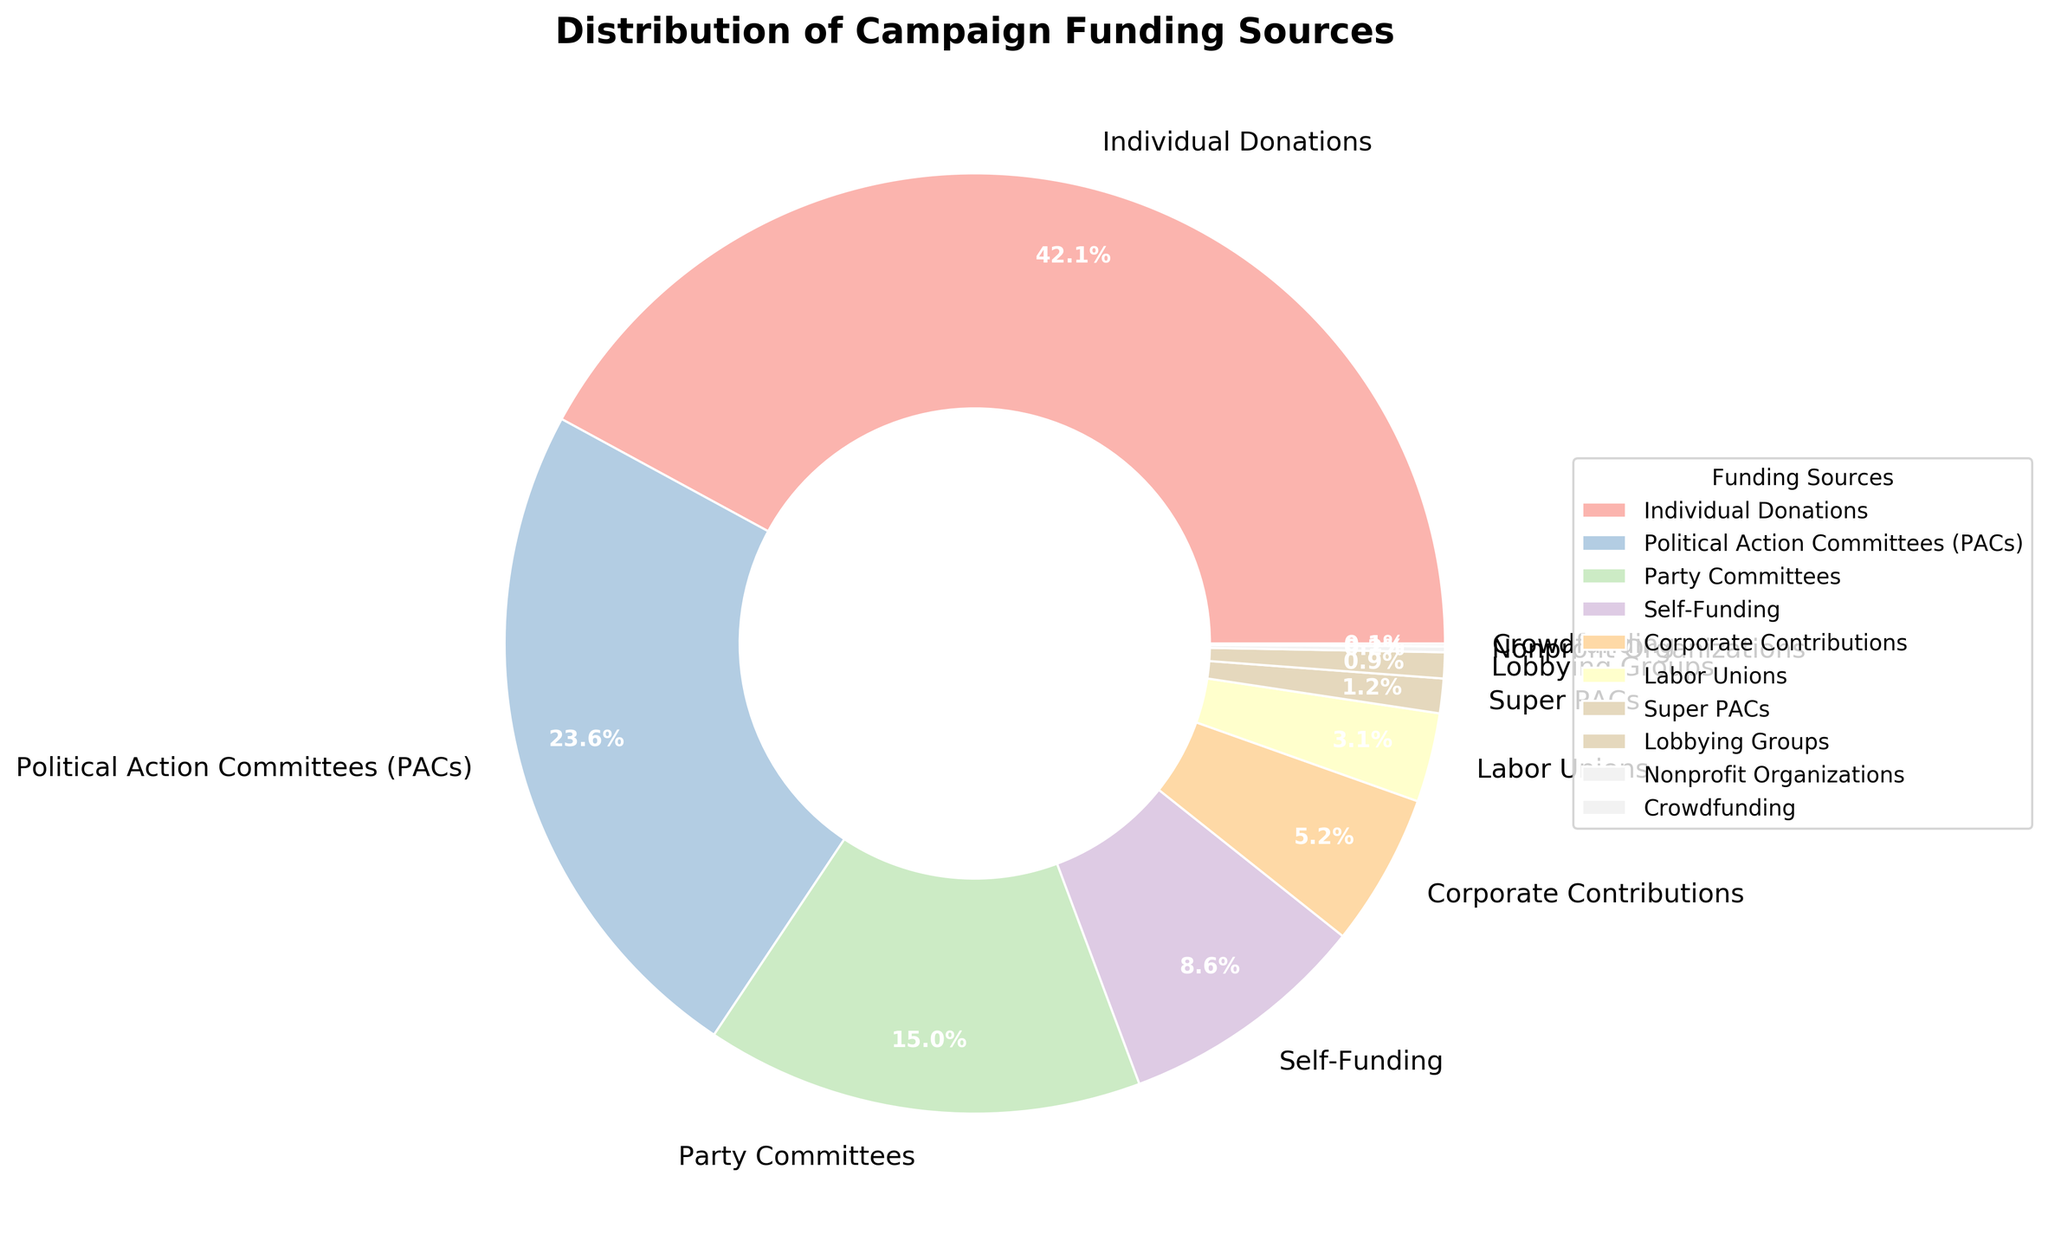Which funding source has the largest percentage? The pie chart shows that "Individual Donations" has the largest slice, representing 42.5% of the total campaign funding sources.
Answer: Individual Donations What is the combined percentage of "Individual Donations" and "Political Action Committees (PACs)"? According to the pie chart, "Individual Donations" account for 42.5% and "Political Action Committees (PACs)" account for 23.8%. Adding these together, 42.5 + 23.8 = 66.3%.
Answer: 66.3% Which two funding sources together account for the smallest percentage? The chart shows that "Crowdfunding" and "Nonprofit Organizations" have the smallest individual percentages at 0.1% and 0.2%, respectively. Together, they sum up to 0.1 + 0.2 = 0.3%.
Answer: Crowdfunding and Nonprofit Organizations By how much does the percentage of "Corporate Contributions" exceed that of "Labor Unions"? From the pie chart, "Corporate Contributions" have a percentage of 5.3%, and "Labor Unions" have 3.1%. The difference is 5.3 - 3.1 = 2.2%.
Answer: 2.2% What is the percentage difference between the largest and the smallest funding sources? The largest funding source is "Individual Donations" at 42.5%, and the smallest is "Crowdfunding" at 0.1%. The difference is 42.5 - 0.1 = 42.4%.
Answer: 42.4% What percentage of the campaign funding comes from "Self-Funding" and "Party Committees" combined? According to the chart, "Self-Funding" has a percentage of 8.7% and "Party Committees" has 15.2%. Adding these together, 8.7 + 15.2 = 23.9%.
Answer: 23.9% How many funding sources have a percentage greater than or equal to 5%? From the pie chart, the funding sources that meet this criterion are "Individual Donations" (42.5%), "Political Action Committees (PACs)" (23.8%), "Party Committees" (15.2%), and "Self-Funding" (8.7%). There are 4 such funding sources.
Answer: 4 What is the total percentage of all sources other than "Individual Donations"? The percentage for "Individual Donations" is 42.5%. The total percentage for all sources is 100%. Therefore, the total for all other sources is 100 - 42.5 = 57.5%.
Answer: 57.5% How does the size of the slice for "Political Action Committees (PACs)" compare visually to other sources? The slice for "Political Action Committees (PACs)" is one of the larger slices in the pie chart, second only to "Individual Donations". It is significantly larger than slices for smaller sources such as "Crowdfunding" and "Nonprofit Organizations".
Answer: One of the larger slices Which funding sources collectively make up less than 10%? The pie chart shows that "Super PACs" (1.2%), "Lobbying Groups" (0.9%), "Nonprofit Organizations" (0.2%), and "Crowdfunding" (0.1%) each have very small percentages. Adding them together gives 1.2 + 0.9 + 0.2 + 0.1 = 2.4%. Therefore, these sources collectively make up less than 10%.
Answer: Super PACs, Lobbying Groups, Nonprofit Organizations, and Crowdfunding 